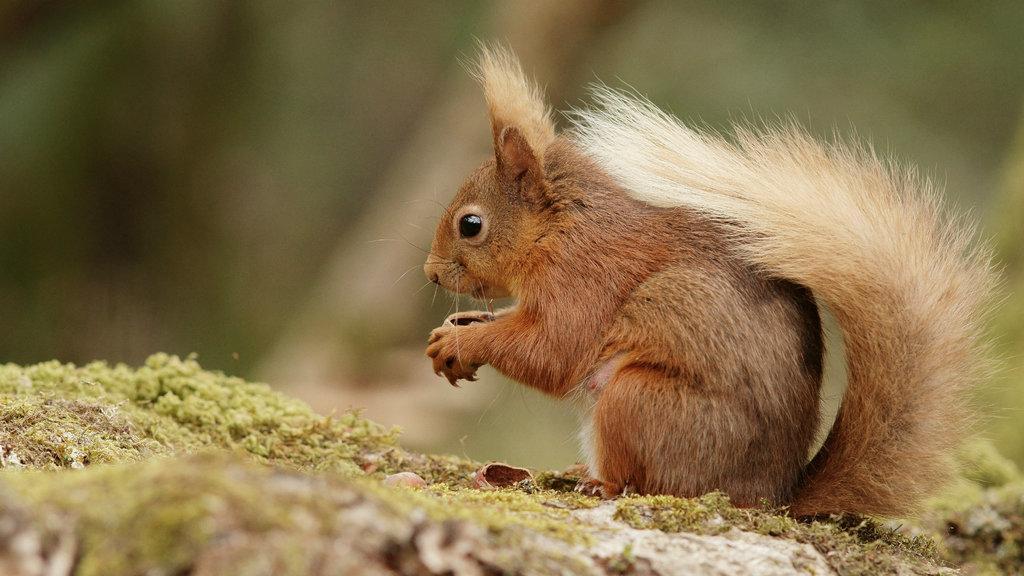Describe this image in one or two sentences. This picture is clicked outside. On the right there is a squirrel sitting on the ground and seems to be holding some object. The background of the image is blur and we can see the small amount of green grass. 